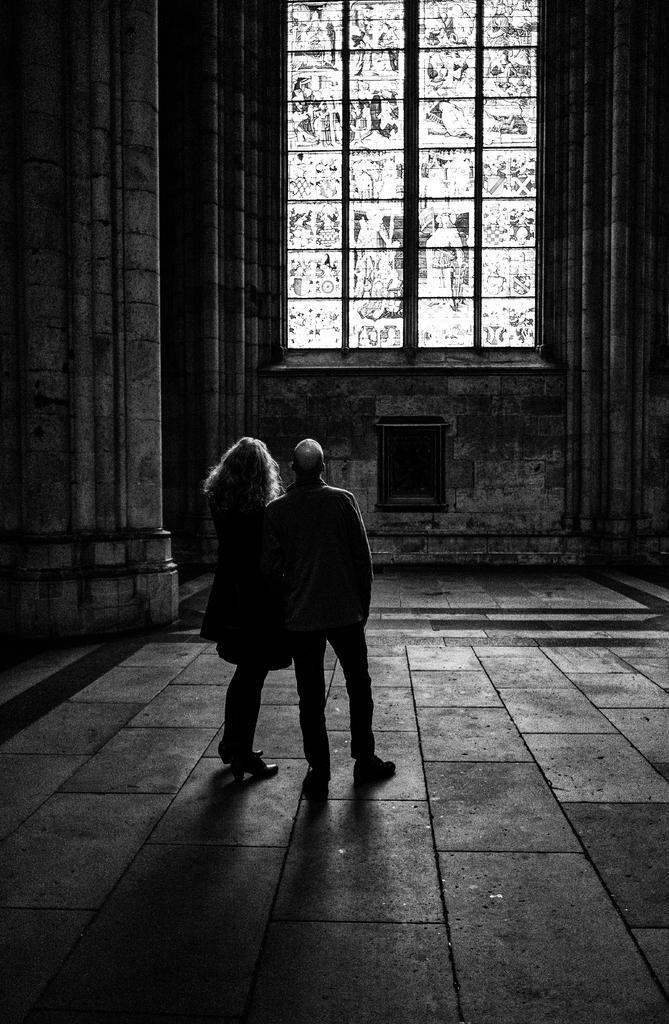How would you summarize this image in a sentence or two? This a black and white image. In this image there are two persons standing. 